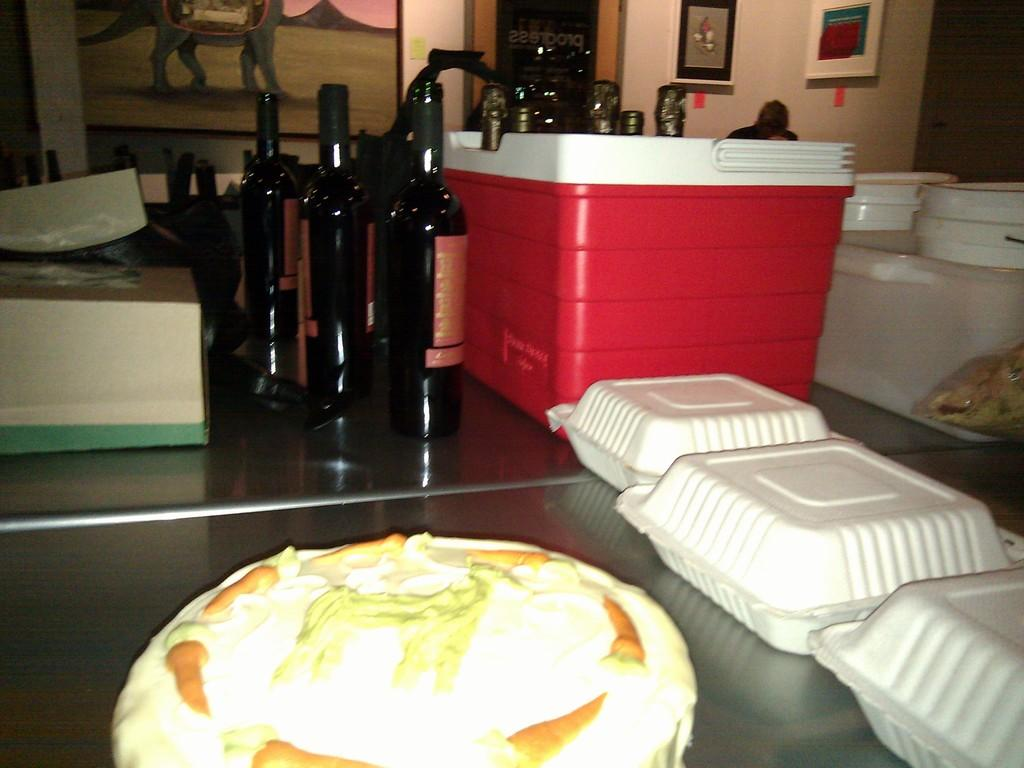How many wine bottles are visible in the image? There are 3 wine bottles in the image. What else can be seen in the image besides the wine bottles? There is food, paper plates, a container, a box, and a table present in the image. What is in the background of the image? In the background of the image, there are buckets, frames attached to the wall, and a door. What might be used for serving or holding food in the image? Paper plates are present in the image for serving or holding food. Can you see a whip being used in the image? No, there is no whip present in the image. 